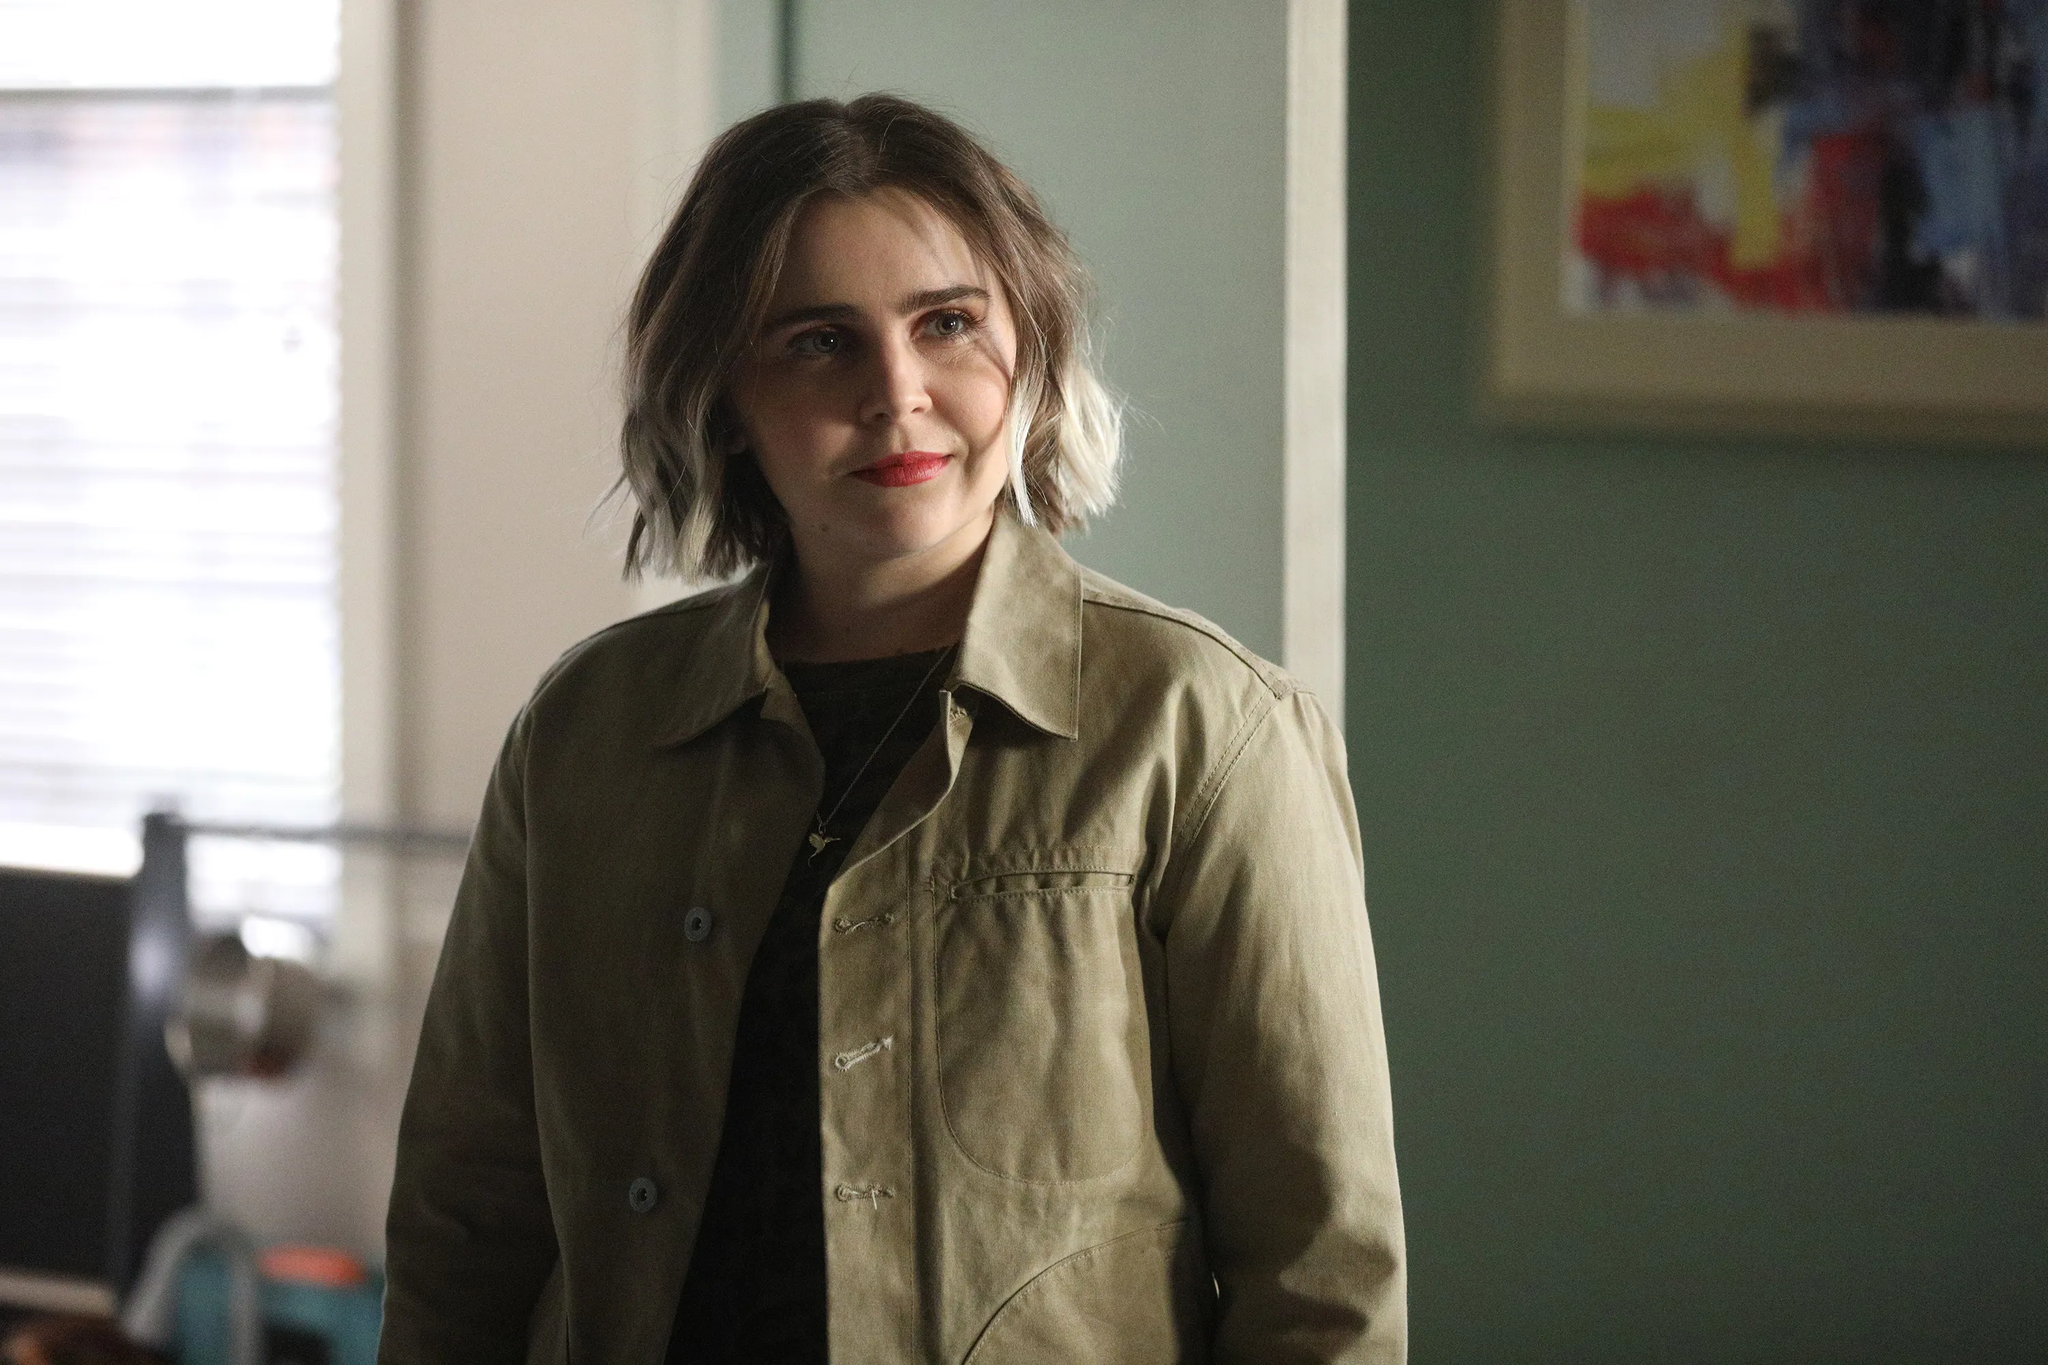Imagine if this character's thoughts could be depicted as abstract art. What would that look like? If this character’s thoughts were depicted as abstract art, the canvas would likely be a blend of soft pastels and bold, vibrant colors. There would be smooth, flowing lines mingled with sharp, decisive strokes, reflecting the blend of calmness and occasional intense emotions. Swirling patterns might indicate deep contemplation, with bursts of bright hues representing moments of joy or inspiration. The painting might convey a sense of thoughtfulness and complexity, showcasing an intricate inner world filled with both serenity and vivid, spontaneous ideas. What might her plans be for the immediate future based on her expression and surroundings? Based on her tranquil expression and the cozy surroundings, it seems she might be planning to enjoy a peaceful moment of leisure. She could be thinking about reading a book, engaging in a creative activity like painting or writing, or perhaps taking a quiet stroll outside to appreciate nature. Her slight smile and relaxed demeanor suggest she's in no rush and is content to spend her time doing something personal and fulfilling. Can you imagine a short story that starts with this scene? In the serene silence of her cozy living room, she stood against the green wall, her eyes reflecting a thousand unsaid words. The abstract painting behind her seemed to vibrate with the sharegpt4v/same boundless energy as her thoughts. Today was the day she had been waiting for—a day of no rush, no errands. A day for dreams. As the light from the window slowly kissed the tips of her blonde hair, she glanced at the paintbrush resting on her table. The world outside her window murmured possibilities, and she knew, deep inside, that she was about to create something beautiful—something that mirrored the depth and color of the painting on her wall. This was not just a day off; it was a day for new beginnings. 